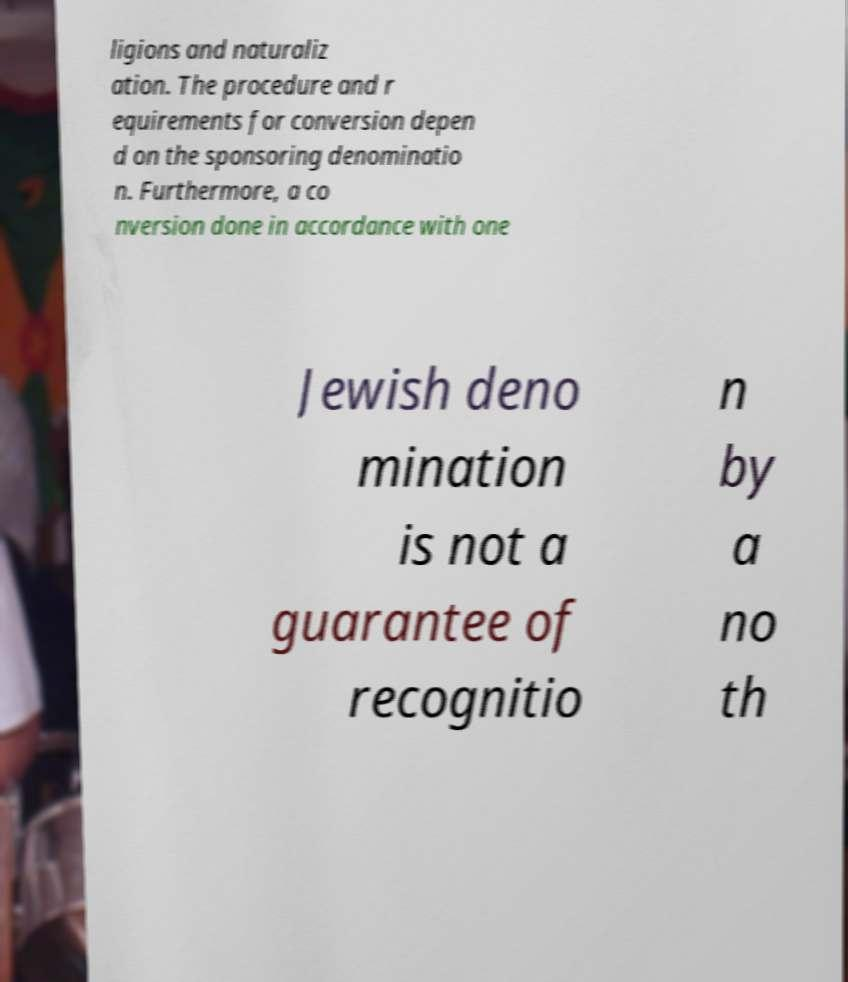Please identify and transcribe the text found in this image. ligions and naturaliz ation. The procedure and r equirements for conversion depen d on the sponsoring denominatio n. Furthermore, a co nversion done in accordance with one Jewish deno mination is not a guarantee of recognitio n by a no th 